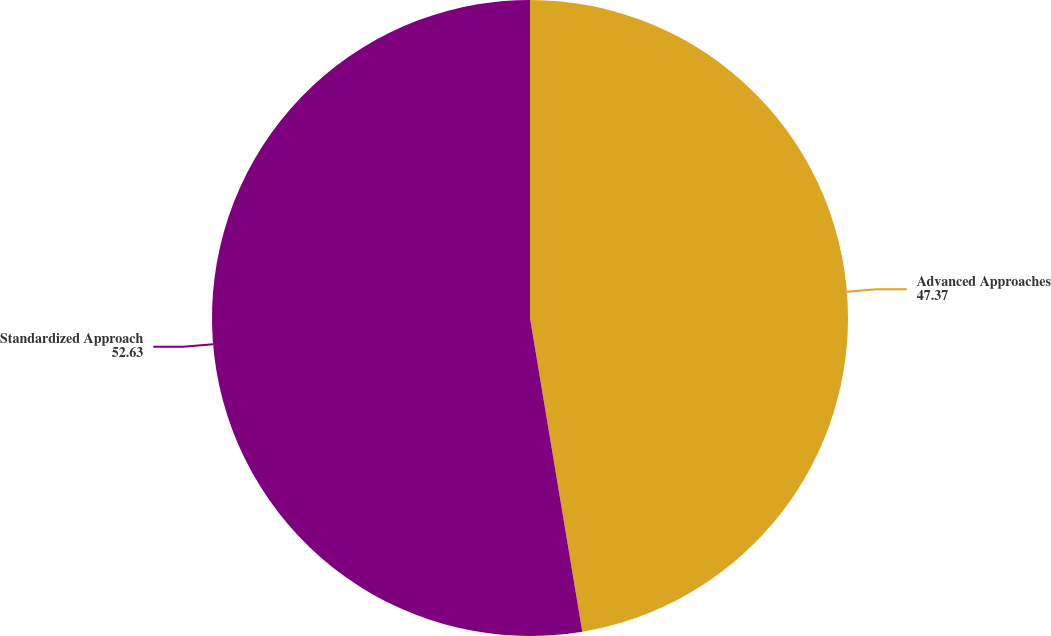Convert chart. <chart><loc_0><loc_0><loc_500><loc_500><pie_chart><fcel>Advanced Approaches<fcel>Standardized Approach<nl><fcel>47.37%<fcel>52.63%<nl></chart> 